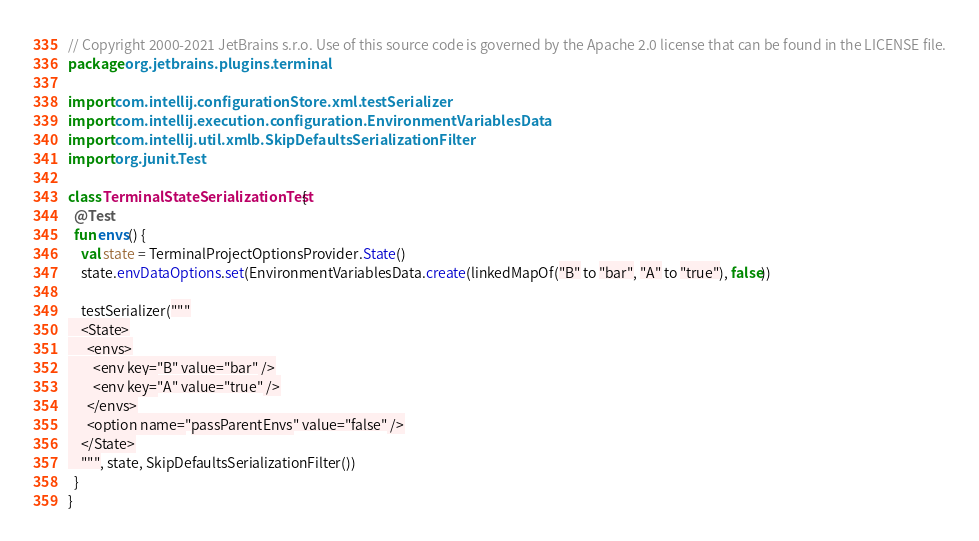Convert code to text. <code><loc_0><loc_0><loc_500><loc_500><_Kotlin_>// Copyright 2000-2021 JetBrains s.r.o. Use of this source code is governed by the Apache 2.0 license that can be found in the LICENSE file.
package org.jetbrains.plugins.terminal

import com.intellij.configurationStore.xml.testSerializer
import com.intellij.execution.configuration.EnvironmentVariablesData
import com.intellij.util.xmlb.SkipDefaultsSerializationFilter
import org.junit.Test

class TerminalStateSerializationTest {
  @Test
  fun envs() {
    val state = TerminalProjectOptionsProvider.State()
    state.envDataOptions.set(EnvironmentVariablesData.create(linkedMapOf("B" to "bar", "A" to "true"), false))

    testSerializer("""
    <State>
      <envs>
        <env key="B" value="bar" />
        <env key="A" value="true" />
      </envs>
      <option name="passParentEnvs" value="false" />
    </State>
    """, state, SkipDefaultsSerializationFilter())
  }
}
</code> 